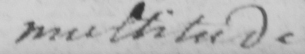Can you tell me what this handwritten text says? multitude 